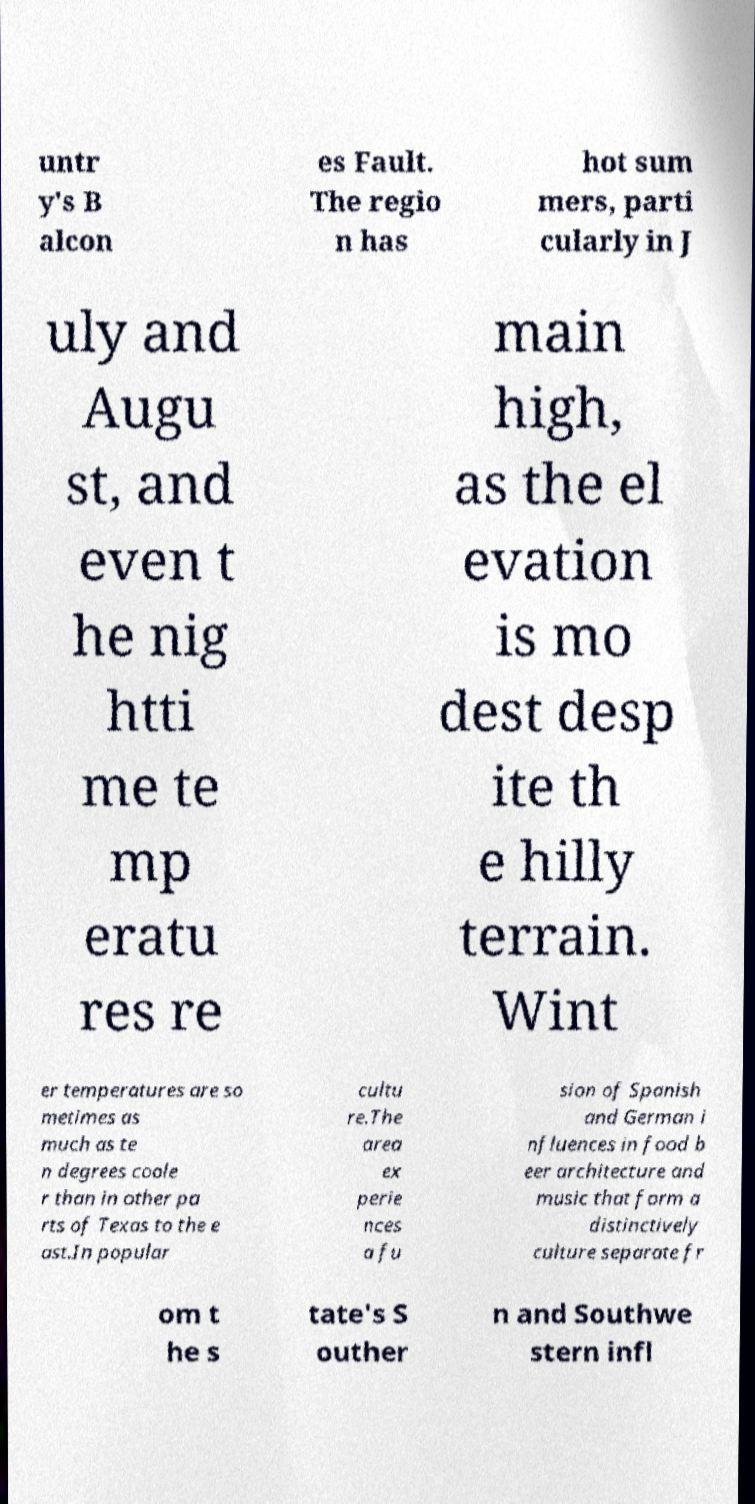What messages or text are displayed in this image? I need them in a readable, typed format. untr y's B alcon es Fault. The regio n has hot sum mers, parti cularly in J uly and Augu st, and even t he nig htti me te mp eratu res re main high, as the el evation is mo dest desp ite th e hilly terrain. Wint er temperatures are so metimes as much as te n degrees coole r than in other pa rts of Texas to the e ast.In popular cultu re.The area ex perie nces a fu sion of Spanish and German i nfluences in food b eer architecture and music that form a distinctively culture separate fr om t he s tate's S outher n and Southwe stern infl 